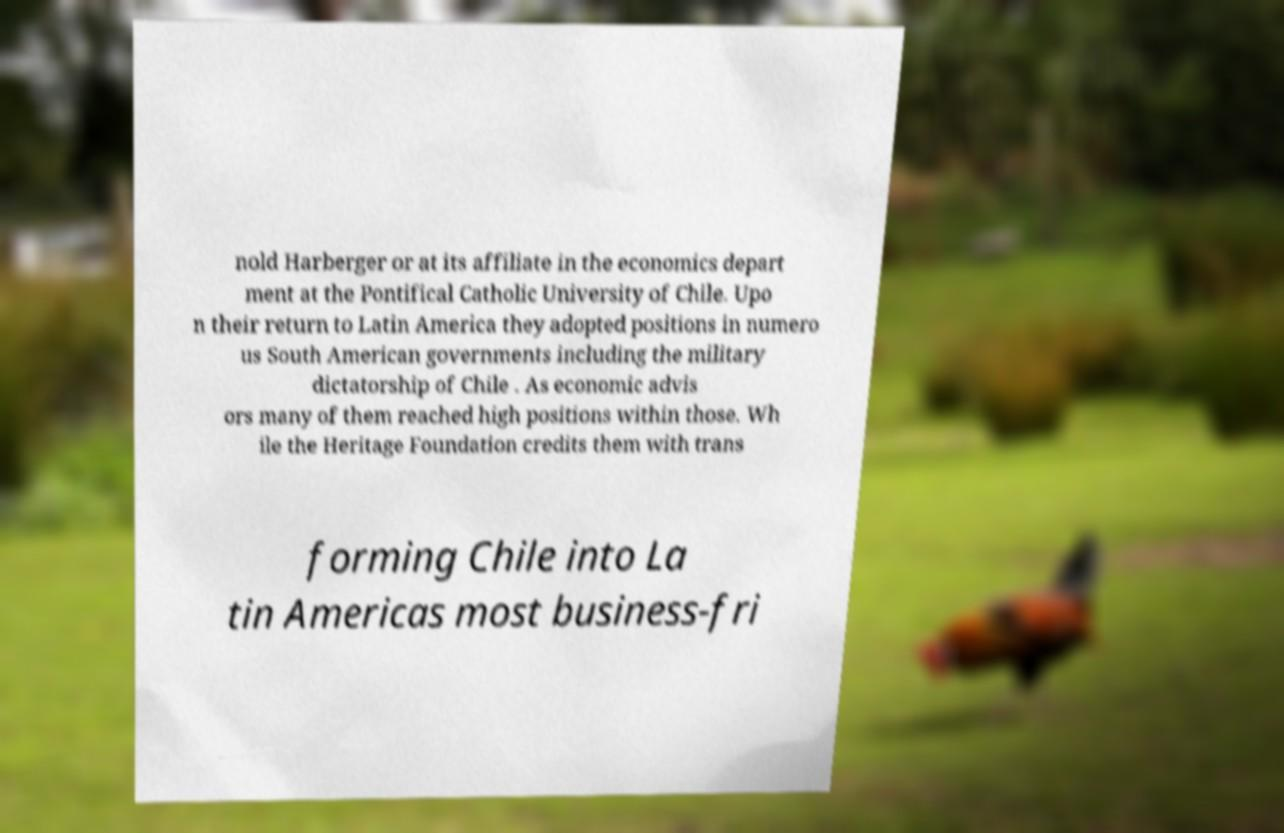Can you accurately transcribe the text from the provided image for me? nold Harberger or at its affiliate in the economics depart ment at the Pontifical Catholic University of Chile. Upo n their return to Latin America they adopted positions in numero us South American governments including the military dictatorship of Chile . As economic advis ors many of them reached high positions within those. Wh ile the Heritage Foundation credits them with trans forming Chile into La tin Americas most business-fri 